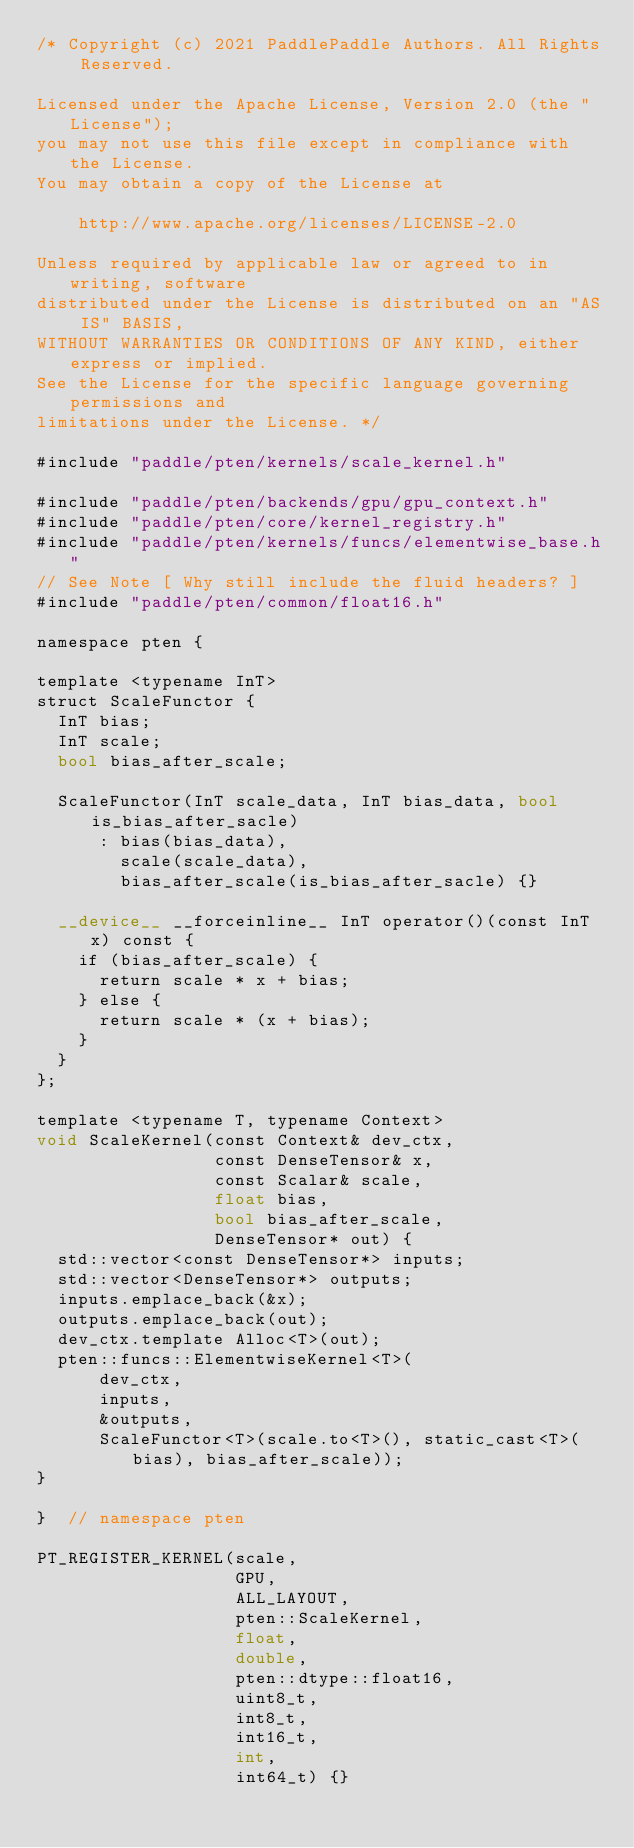<code> <loc_0><loc_0><loc_500><loc_500><_Cuda_>/* Copyright (c) 2021 PaddlePaddle Authors. All Rights Reserved.

Licensed under the Apache License, Version 2.0 (the "License");
you may not use this file except in compliance with the License.
You may obtain a copy of the License at

    http://www.apache.org/licenses/LICENSE-2.0

Unless required by applicable law or agreed to in writing, software
distributed under the License is distributed on an "AS IS" BASIS,
WITHOUT WARRANTIES OR CONDITIONS OF ANY KIND, either express or implied.
See the License for the specific language governing permissions and
limitations under the License. */

#include "paddle/pten/kernels/scale_kernel.h"

#include "paddle/pten/backends/gpu/gpu_context.h"
#include "paddle/pten/core/kernel_registry.h"
#include "paddle/pten/kernels/funcs/elementwise_base.h"
// See Note [ Why still include the fluid headers? ]
#include "paddle/pten/common/float16.h"

namespace pten {

template <typename InT>
struct ScaleFunctor {
  InT bias;
  InT scale;
  bool bias_after_scale;

  ScaleFunctor(InT scale_data, InT bias_data, bool is_bias_after_sacle)
      : bias(bias_data),
        scale(scale_data),
        bias_after_scale(is_bias_after_sacle) {}

  __device__ __forceinline__ InT operator()(const InT x) const {
    if (bias_after_scale) {
      return scale * x + bias;
    } else {
      return scale * (x + bias);
    }
  }
};

template <typename T, typename Context>
void ScaleKernel(const Context& dev_ctx,
                 const DenseTensor& x,
                 const Scalar& scale,
                 float bias,
                 bool bias_after_scale,
                 DenseTensor* out) {
  std::vector<const DenseTensor*> inputs;
  std::vector<DenseTensor*> outputs;
  inputs.emplace_back(&x);
  outputs.emplace_back(out);
  dev_ctx.template Alloc<T>(out);
  pten::funcs::ElementwiseKernel<T>(
      dev_ctx,
      inputs,
      &outputs,
      ScaleFunctor<T>(scale.to<T>(), static_cast<T>(bias), bias_after_scale));
}

}  // namespace pten

PT_REGISTER_KERNEL(scale,
                   GPU,
                   ALL_LAYOUT,
                   pten::ScaleKernel,
                   float,
                   double,
                   pten::dtype::float16,
                   uint8_t,
                   int8_t,
                   int16_t,
                   int,
                   int64_t) {}
</code> 